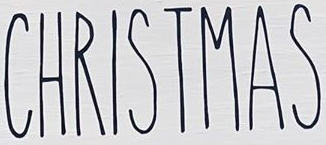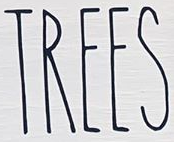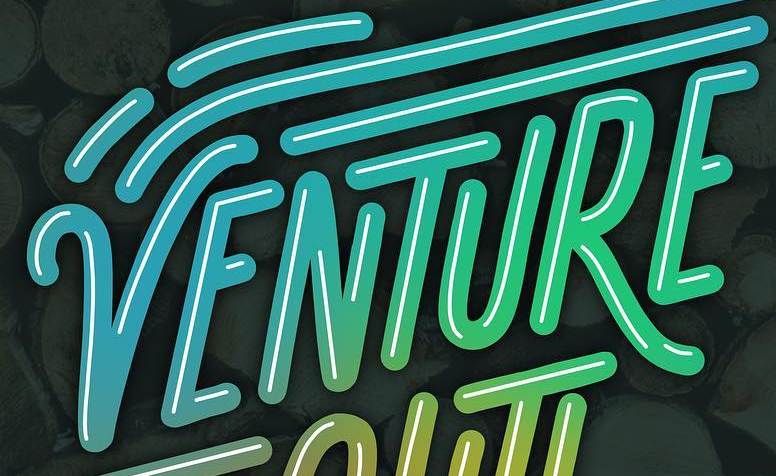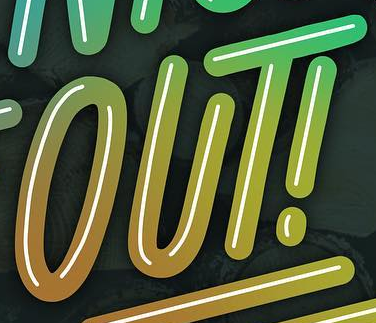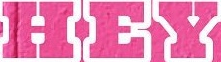Read the text from these images in sequence, separated by a semicolon. CHRISTMAS; TREES; VENTURE; OUT!; HEY 